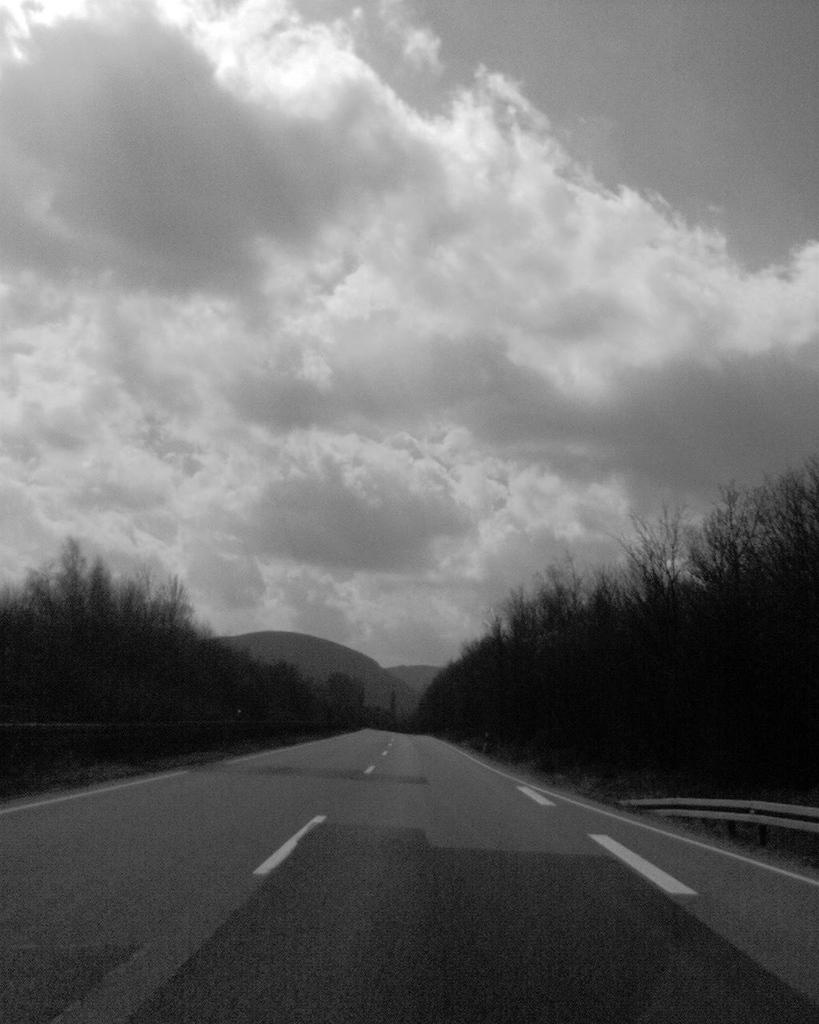What is the color scheme of the image? The image is black and white. What can be seen on the ground in the image? There is a road in the image. What distinguishes the road in the image? The road has white lines. What type of natural elements are present in the image? There are trees in the image. What is visible in the background of the image? The sky is visible in the background of the image. How would you describe the weather based on the image? The sky appears to be cloudy, which might suggest overcast or potentially rainy weather. What type of tools does the carpenter use in the image? There is no carpenter present in the image, so it is not possible to answer that question. 